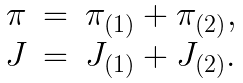<formula> <loc_0><loc_0><loc_500><loc_500>\begin{array} { r c l } \pi & = & \pi _ { ( 1 ) } + \pi _ { ( 2 ) } , \\ J & = & J _ { ( 1 ) } + J _ { ( 2 ) } . \end{array}</formula> 